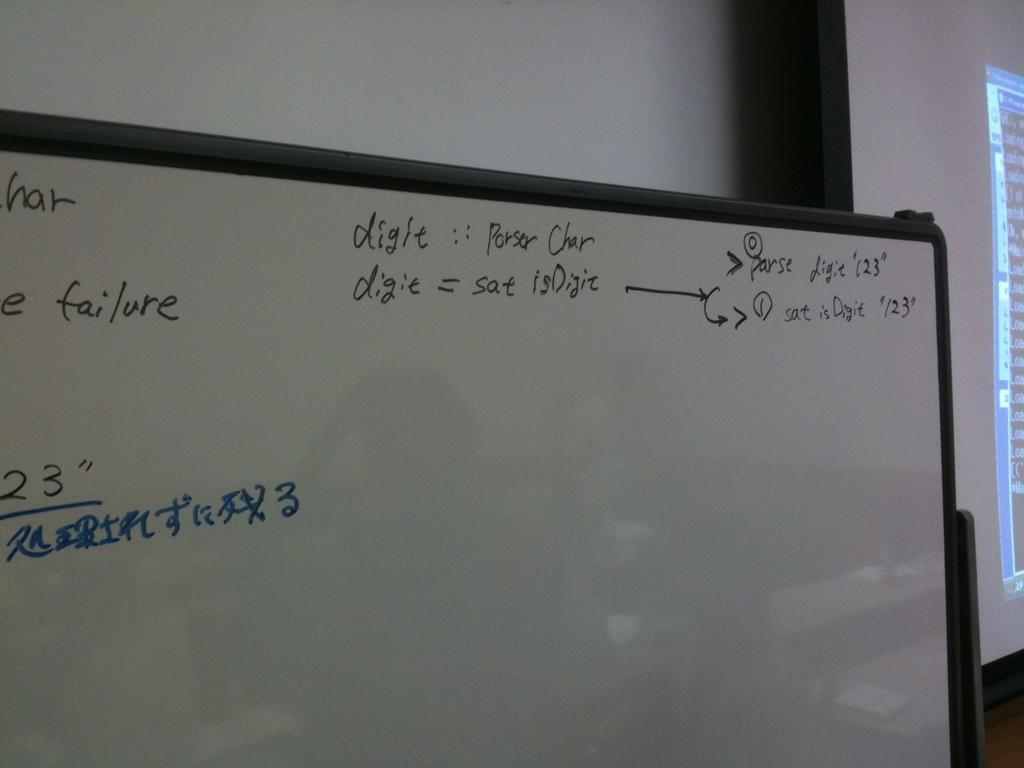<image>
Write a terse but informative summary of the picture. a white board that has digit written in 2 places 